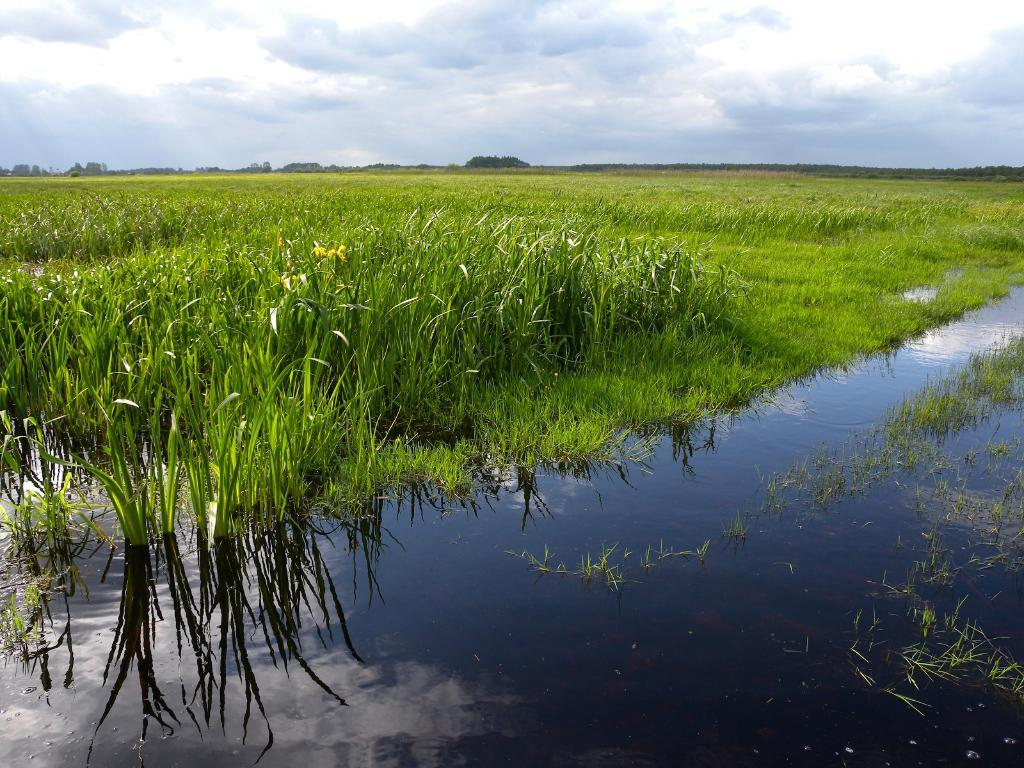What is the primary element visible in the image? There is water in the image. What type of surface can be seen near the water? There is a grass surface with grass plants in the image. What type of vegetation is visible in the image? There are trees visible in the image. What is visible above the water and trees? The sky is visible in the image. What can be observed in the sky? Clouds are present in the sky. How many hydrants are visible in the image? There are no hydrants present in the image. What memories are being triggered by the image? The image does not contain any specific memories, as it is a visual representation of a scene with water, grass, trees, and sky. 